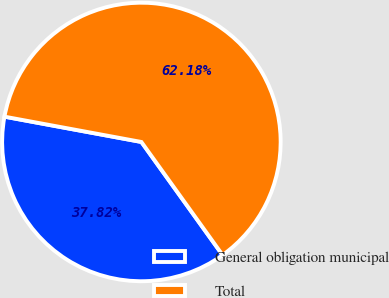<chart> <loc_0><loc_0><loc_500><loc_500><pie_chart><fcel>General obligation municipal<fcel>Total<nl><fcel>37.82%<fcel>62.18%<nl></chart> 